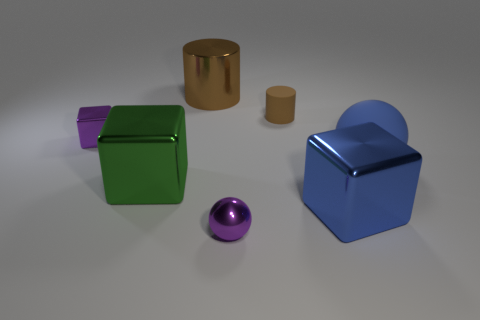Add 2 large gray cylinders. How many objects exist? 9 Subtract all spheres. How many objects are left? 5 Subtract 0 gray blocks. How many objects are left? 7 Subtract all blue shiny things. Subtract all small purple objects. How many objects are left? 4 Add 5 tiny brown cylinders. How many tiny brown cylinders are left? 6 Add 1 large green metal spheres. How many large green metal spheres exist? 1 